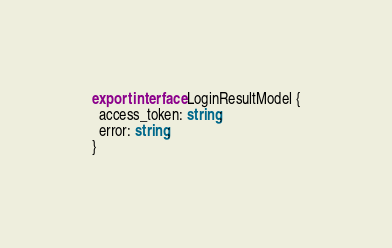<code> <loc_0><loc_0><loc_500><loc_500><_TypeScript_>export interface LoginResultModel {
  access_token: string;
  error: string;
}
</code> 